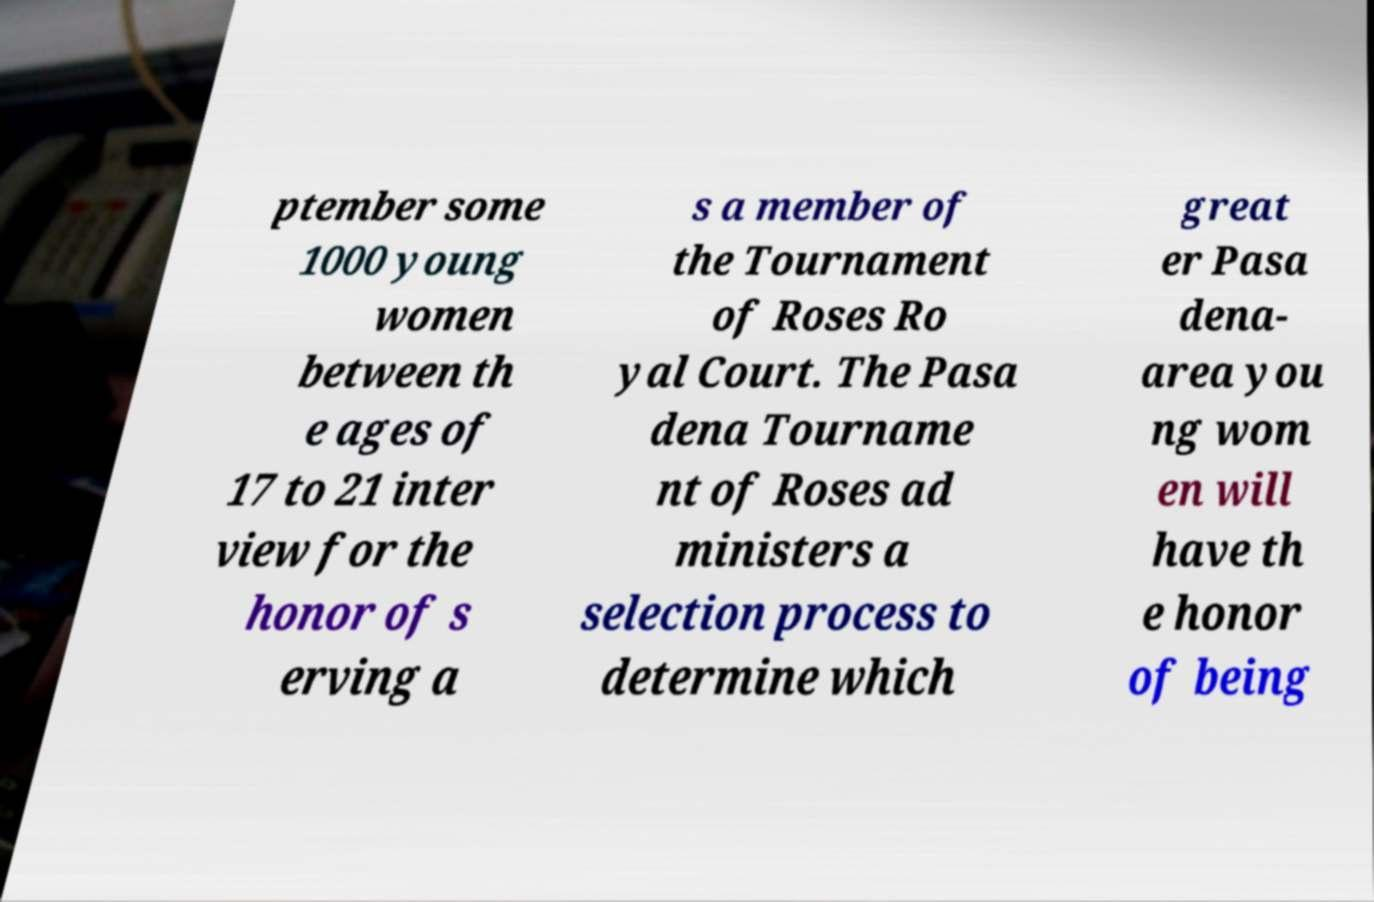Can you accurately transcribe the text from the provided image for me? ptember some 1000 young women between th e ages of 17 to 21 inter view for the honor of s erving a s a member of the Tournament of Roses Ro yal Court. The Pasa dena Tourname nt of Roses ad ministers a selection process to determine which great er Pasa dena- area you ng wom en will have th e honor of being 